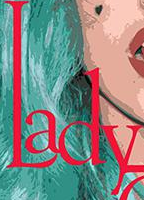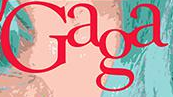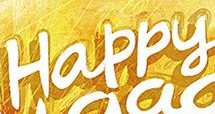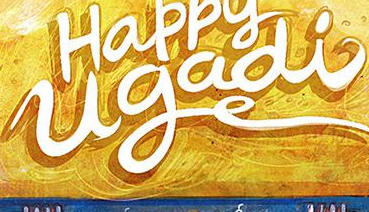What text is displayed in these images sequentially, separated by a semicolon? Lady; Gaga; Happy; ugadi 